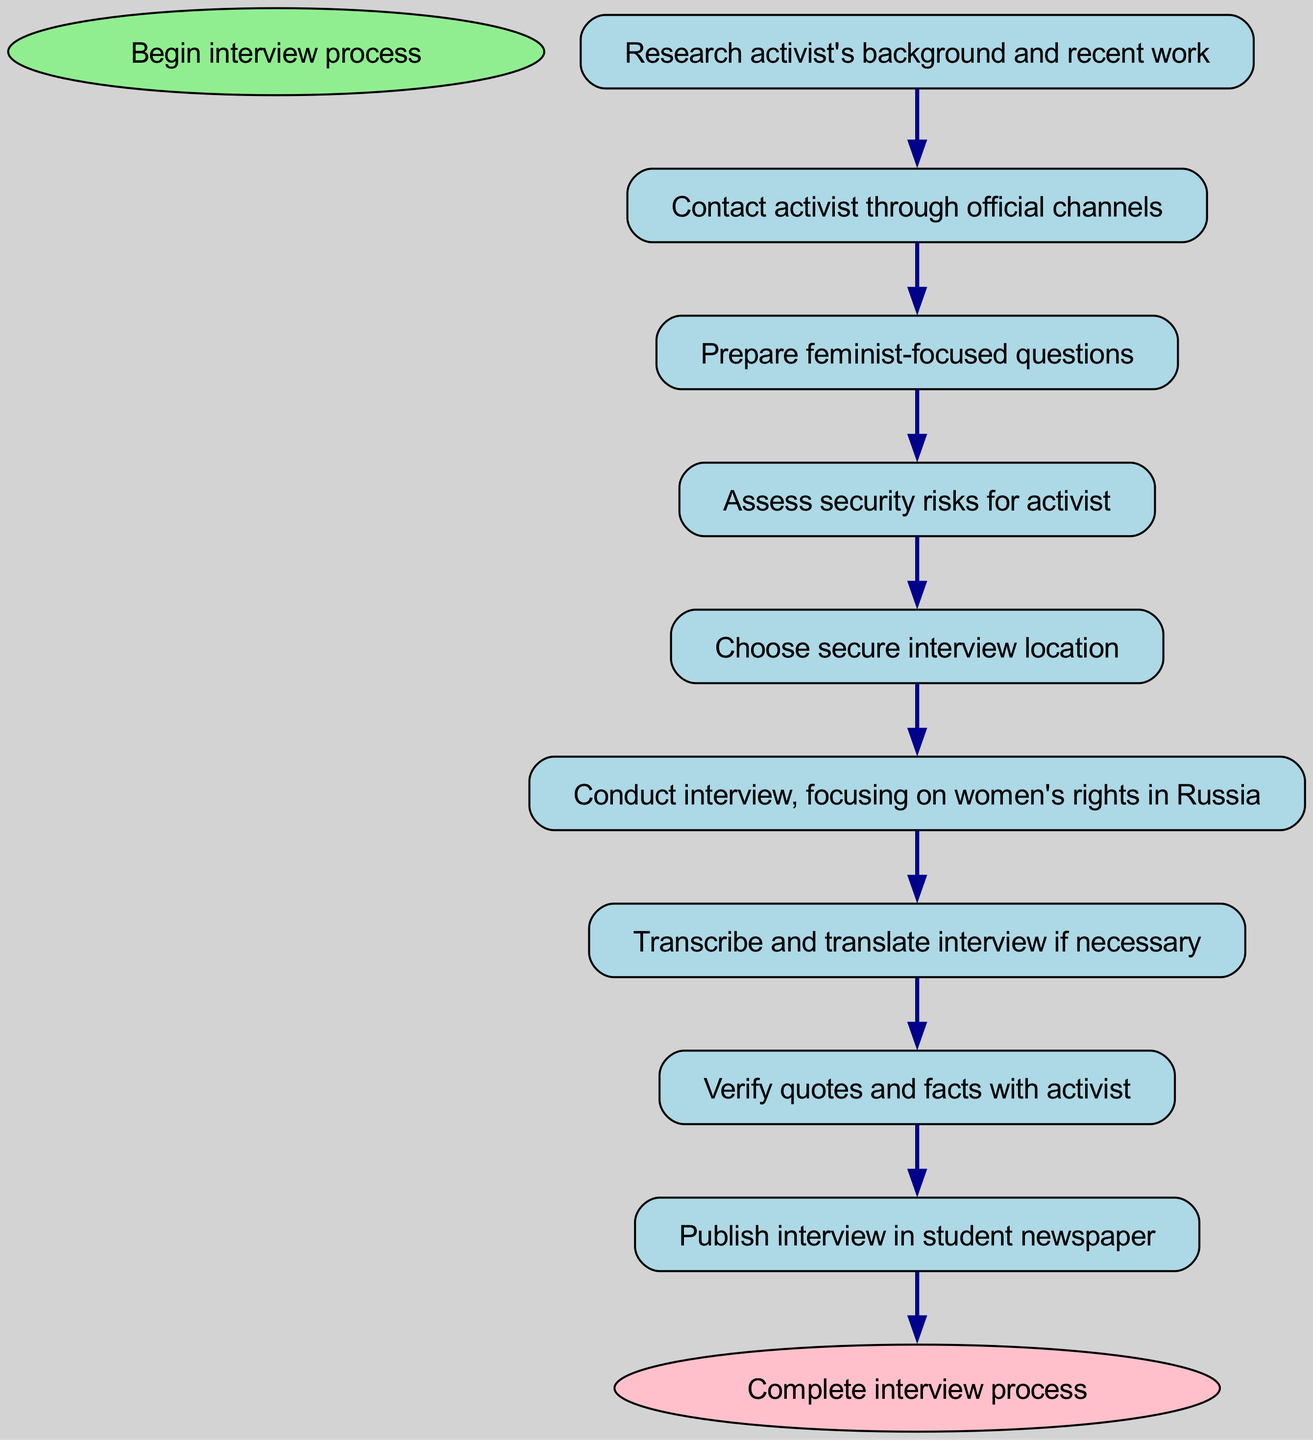What is the first step in the interview process? The first step is stated as "Begin interview process," which is the starting point of the workflow.
Answer: Begin interview process How many steps are there in the workflow? There are 8 steps identified in the workflow before reaching the end.
Answer: 8 What is the last action to be taken in the workflow? The last action is to "Publish interview in student newspaper," which is the final step before completing the process.
Answer: Publish interview in student newspaper Which step follows "Conduct interview, focusing on women's rights in Russia"? According to the sequence in the workflow, the next step after conducting the interview is "Transcribe and translate interview if necessary."
Answer: Transcribe and translate interview if necessary What is assessed right before choosing a secure interview location? "Assess security risks for activist" is the step taken right before selecting the location, highlighting the importance of safety in the process.
Answer: Assess security risks for activist What are the two main focuses of the interview conducted in the workflow? The main focuses are on "women's rights in Russia" during the interview process and "feminist-focused questions" prepared beforehand.
Answer: Women's rights in Russia What does the step "Verify quotes and facts with activist" emphasize about the interview process? This step emphasizes the importance of accuracy and validation in journalism, ensuring that the activist's statements are correctly represented.
Answer: Accuracy and validation What is the purpose of choosing a secure interview location? The purpose of selecting a secure interview location is to ensure the safety of the activist and to mitigate any potential risks associated with the interview.
Answer: Safety of the activist 